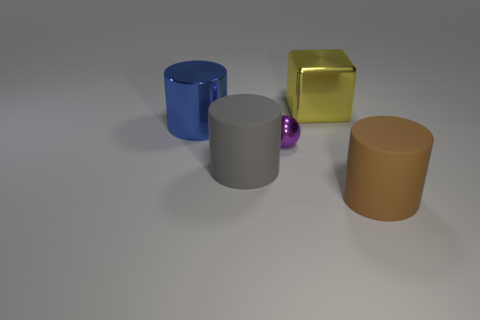Is there anything else that is the same size as the purple ball?
Your answer should be very brief. No. Are there more yellow metal objects that are right of the yellow thing than large brown rubber cylinders behind the big blue metallic cylinder?
Provide a succinct answer. No. There is a gray thing that is the same material as the large brown cylinder; what shape is it?
Your answer should be very brief. Cylinder. Is the number of big yellow metal objects behind the shiny ball greater than the number of green things?
Provide a short and direct response. Yes. What number of shiny cylinders have the same color as the shiny cube?
Offer a very short reply. 0. Are there more big brown cylinders than small green metallic cylinders?
Keep it short and to the point. Yes. What is the material of the purple object?
Make the answer very short. Metal. There is a cylinder that is right of the gray matte thing; does it have the same size as the big gray matte thing?
Provide a short and direct response. Yes. What is the size of the metallic thing on the left side of the purple shiny ball?
Give a very brief answer. Large. How many large cylinders are there?
Offer a terse response. 3. 